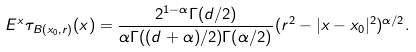Convert formula to latex. <formula><loc_0><loc_0><loc_500><loc_500>E ^ { x } \tau _ { B ( x _ { 0 } , r ) } ( x ) = \frac { 2 ^ { 1 - \alpha } \Gamma ( d / 2 ) } { \alpha \Gamma ( ( d + \alpha ) / 2 ) \Gamma ( \alpha / 2 ) } ( r ^ { 2 } - | x - x _ { 0 } | ^ { 2 } ) ^ { \alpha / 2 } .</formula> 